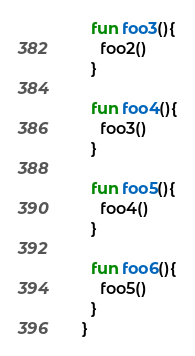<code> <loc_0><loc_0><loc_500><loc_500><_Kotlin_>  fun foo3(){
    foo2()
  }

  fun foo4(){
    foo3()
  }

  fun foo5(){
    foo4()
  }

  fun foo6(){
    foo5()
  }
}</code> 